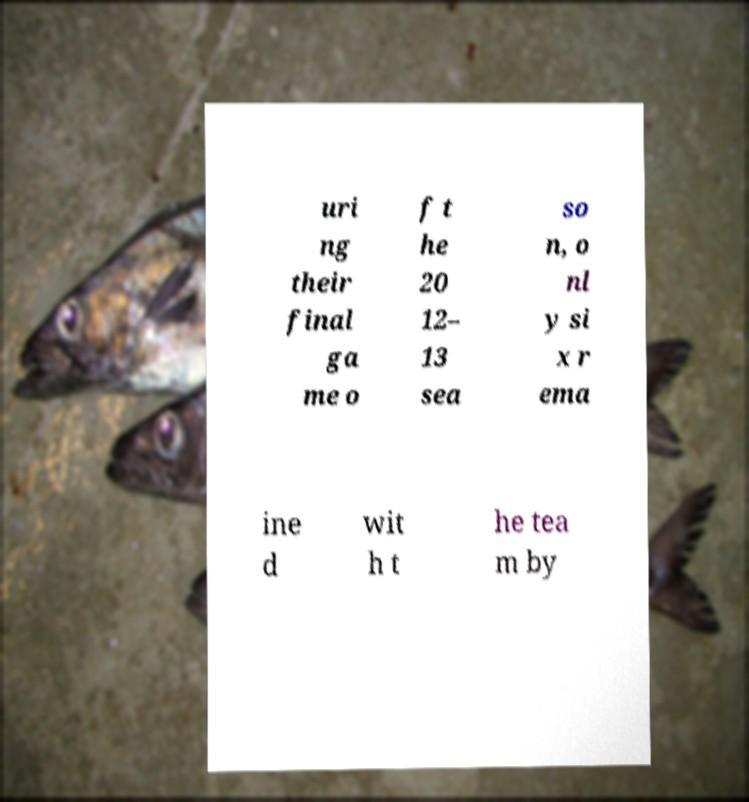Can you read and provide the text displayed in the image?This photo seems to have some interesting text. Can you extract and type it out for me? uri ng their final ga me o f t he 20 12– 13 sea so n, o nl y si x r ema ine d wit h t he tea m by 